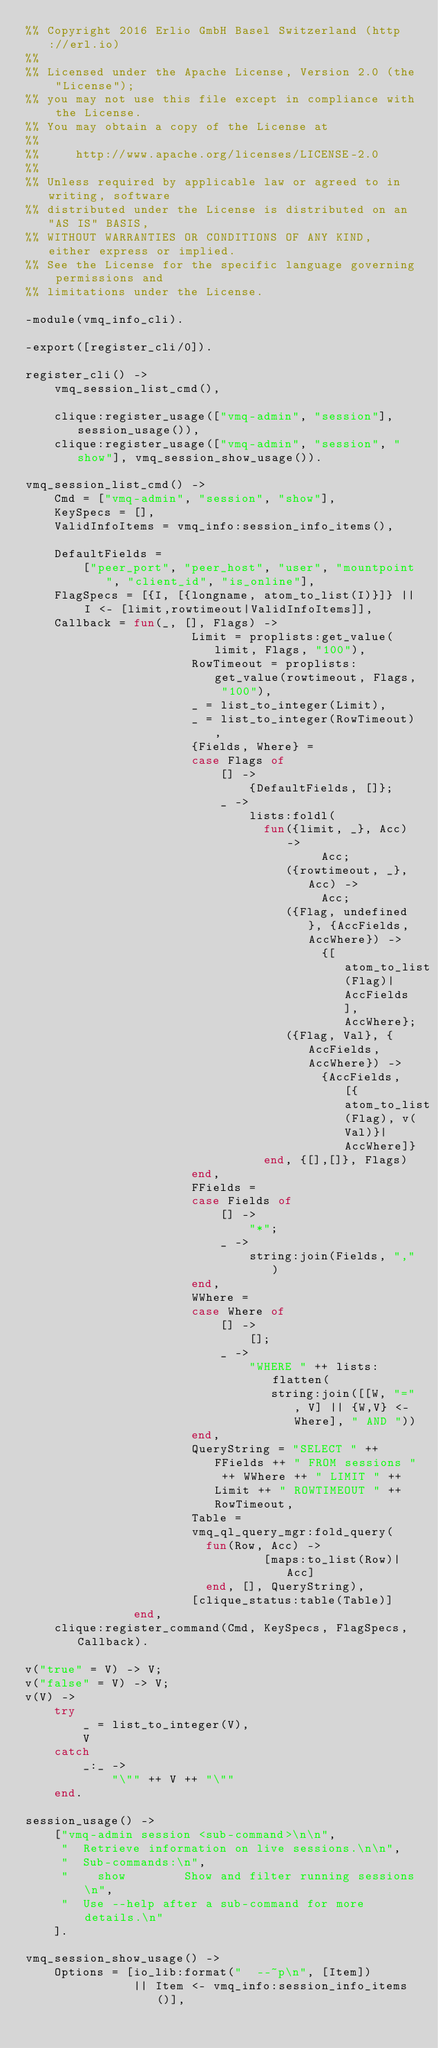Convert code to text. <code><loc_0><loc_0><loc_500><loc_500><_Erlang_>%% Copyright 2016 Erlio GmbH Basel Switzerland (http://erl.io)
%%
%% Licensed under the Apache License, Version 2.0 (the "License");
%% you may not use this file except in compliance with the License.
%% You may obtain a copy of the License at
%%
%%     http://www.apache.org/licenses/LICENSE-2.0
%%
%% Unless required by applicable law or agreed to in writing, software
%% distributed under the License is distributed on an "AS IS" BASIS,
%% WITHOUT WARRANTIES OR CONDITIONS OF ANY KIND, either express or implied.
%% See the License for the specific language governing permissions and
%% limitations under the License.

-module(vmq_info_cli).

-export([register_cli/0]).

register_cli() ->
    vmq_session_list_cmd(),

    clique:register_usage(["vmq-admin", "session"], session_usage()),
    clique:register_usage(["vmq-admin", "session", "show"], vmq_session_show_usage()).

vmq_session_list_cmd() ->
    Cmd = ["vmq-admin", "session", "show"],
    KeySpecs = [],
    ValidInfoItems = vmq_info:session_info_items(),

    DefaultFields =
        ["peer_port", "peer_host", "user", "mountpoint", "client_id", "is_online"],
    FlagSpecs = [{I, [{longname, atom_to_list(I)}]} || I <- [limit,rowtimeout|ValidInfoItems]],
    Callback = fun(_, [], Flags) ->
                       Limit = proplists:get_value(limit, Flags, "100"),
                       RowTimeout = proplists:get_value(rowtimeout, Flags, "100"),
                       _ = list_to_integer(Limit),
                       _ = list_to_integer(RowTimeout),
                       {Fields, Where} =
                       case Flags of
                           [] ->
                               {DefaultFields, []};
                           _ ->
                               lists:foldl(
                                 fun({limit, _}, Acc) ->
                                         Acc;
                                    ({rowtimeout, _}, Acc) ->
                                         Acc;
                                    ({Flag, undefined}, {AccFields, AccWhere}) ->
                                         {[atom_to_list(Flag)|AccFields], AccWhere};
                                    ({Flag, Val}, {AccFields, AccWhere}) ->
                                         {AccFields, [{atom_to_list(Flag), v(Val)}|AccWhere]}
                                 end, {[],[]}, Flags)
                       end,
                       FFields =
                       case Fields of
                           [] ->
                               "*";
                           _ ->
                               string:join(Fields, ",")
                       end,
                       WWhere =
                       case Where of
                           [] ->
                               [];
                           _ ->
                               "WHERE " ++ lists:flatten(
                                  string:join([[W, "=", V] || {W,V} <- Where], " AND "))
                       end,
                       QueryString = "SELECT " ++ FFields ++ " FROM sessions " ++ WWhere ++ " LIMIT " ++ Limit ++ " ROWTIMEOUT " ++ RowTimeout,
                       Table =
                       vmq_ql_query_mgr:fold_query(
                         fun(Row, Acc) ->
                                 [maps:to_list(Row)|Acc]
                         end, [], QueryString),
                       [clique_status:table(Table)]
               end,
    clique:register_command(Cmd, KeySpecs, FlagSpecs, Callback).

v("true" = V) -> V;
v("false" = V) -> V;
v(V) ->
    try
        _ = list_to_integer(V),
        V
    catch
        _:_ ->
            "\"" ++ V ++ "\""
    end.

session_usage() ->
    ["vmq-admin session <sub-command>\n\n",
     "  Retrieve information on live sessions.\n\n",
     "  Sub-commands:\n",
     "    show        Show and filter running sessions\n",
     "  Use --help after a sub-command for more details.\n"
    ].

vmq_session_show_usage() ->
    Options = [io_lib:format("  --~p\n", [Item])
               || Item <- vmq_info:session_info_items()],</code> 